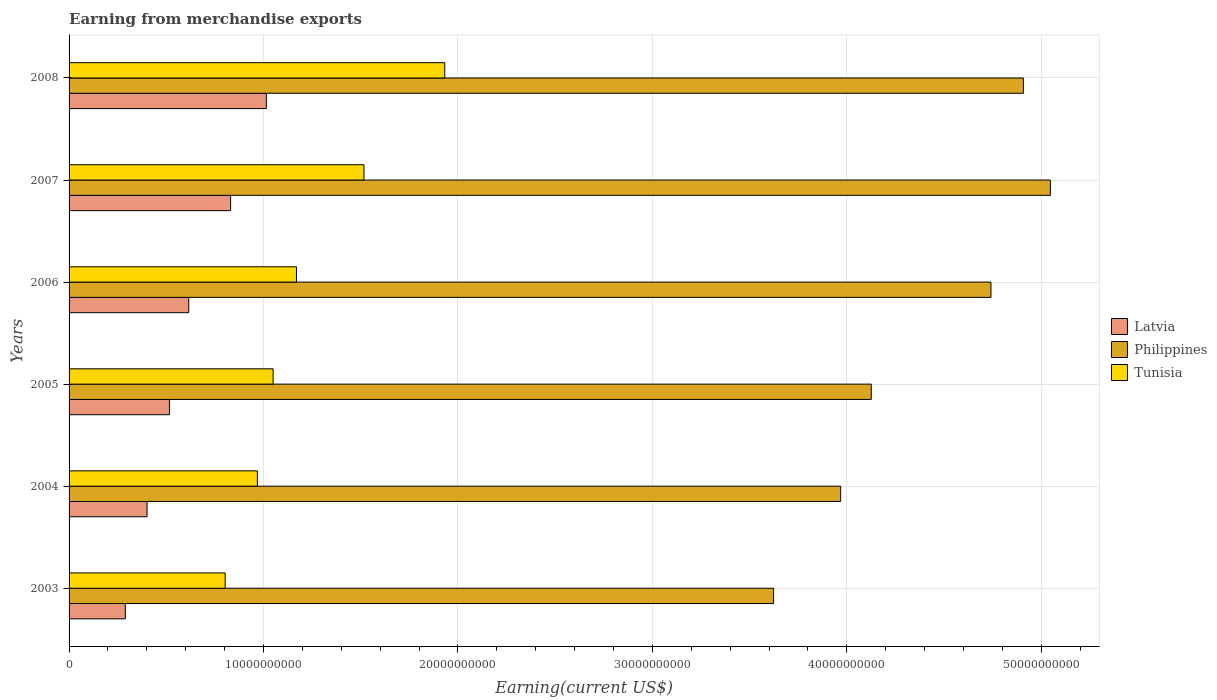How many different coloured bars are there?
Provide a short and direct response. 3. Are the number of bars per tick equal to the number of legend labels?
Ensure brevity in your answer.  Yes. How many bars are there on the 5th tick from the top?
Keep it short and to the point. 3. How many bars are there on the 6th tick from the bottom?
Make the answer very short. 3. What is the label of the 5th group of bars from the top?
Ensure brevity in your answer.  2004. In how many cases, is the number of bars for a given year not equal to the number of legend labels?
Make the answer very short. 0. What is the amount earned from merchandise exports in Latvia in 2004?
Ensure brevity in your answer.  4.01e+09. Across all years, what is the maximum amount earned from merchandise exports in Philippines?
Give a very brief answer. 5.05e+1. Across all years, what is the minimum amount earned from merchandise exports in Tunisia?
Provide a short and direct response. 8.03e+09. In which year was the amount earned from merchandise exports in Tunisia minimum?
Your response must be concise. 2003. What is the total amount earned from merchandise exports in Latvia in the graph?
Offer a terse response. 3.67e+1. What is the difference between the amount earned from merchandise exports in Philippines in 2003 and that in 2004?
Your answer should be compact. -3.45e+09. What is the difference between the amount earned from merchandise exports in Tunisia in 2006 and the amount earned from merchandise exports in Philippines in 2007?
Give a very brief answer. -3.88e+1. What is the average amount earned from merchandise exports in Tunisia per year?
Offer a very short reply. 1.24e+1. In the year 2006, what is the difference between the amount earned from merchandise exports in Philippines and amount earned from merchandise exports in Tunisia?
Your answer should be compact. 3.57e+1. In how many years, is the amount earned from merchandise exports in Latvia greater than 8000000000 US$?
Provide a short and direct response. 2. What is the ratio of the amount earned from merchandise exports in Latvia in 2003 to that in 2006?
Your answer should be very brief. 0.47. Is the amount earned from merchandise exports in Tunisia in 2004 less than that in 2005?
Offer a terse response. Yes. Is the difference between the amount earned from merchandise exports in Philippines in 2003 and 2007 greater than the difference between the amount earned from merchandise exports in Tunisia in 2003 and 2007?
Your answer should be very brief. No. What is the difference between the highest and the second highest amount earned from merchandise exports in Latvia?
Give a very brief answer. 1.84e+09. What is the difference between the highest and the lowest amount earned from merchandise exports in Philippines?
Ensure brevity in your answer.  1.42e+1. In how many years, is the amount earned from merchandise exports in Tunisia greater than the average amount earned from merchandise exports in Tunisia taken over all years?
Ensure brevity in your answer.  2. What does the 3rd bar from the top in 2006 represents?
Give a very brief answer. Latvia. What does the 1st bar from the bottom in 2007 represents?
Keep it short and to the point. Latvia. How many bars are there?
Offer a terse response. 18. How many years are there in the graph?
Your answer should be very brief. 6. Are the values on the major ticks of X-axis written in scientific E-notation?
Your answer should be very brief. No. How are the legend labels stacked?
Provide a succinct answer. Vertical. What is the title of the graph?
Your response must be concise. Earning from merchandise exports. Does "Middle East & North Africa (developing only)" appear as one of the legend labels in the graph?
Provide a short and direct response. No. What is the label or title of the X-axis?
Give a very brief answer. Earning(current US$). What is the Earning(current US$) of Latvia in 2003?
Your answer should be very brief. 2.89e+09. What is the Earning(current US$) in Philippines in 2003?
Make the answer very short. 3.62e+1. What is the Earning(current US$) in Tunisia in 2003?
Ensure brevity in your answer.  8.03e+09. What is the Earning(current US$) in Latvia in 2004?
Offer a very short reply. 4.01e+09. What is the Earning(current US$) of Philippines in 2004?
Give a very brief answer. 3.97e+1. What is the Earning(current US$) of Tunisia in 2004?
Provide a succinct answer. 9.68e+09. What is the Earning(current US$) of Latvia in 2005?
Your response must be concise. 5.16e+09. What is the Earning(current US$) of Philippines in 2005?
Offer a terse response. 4.13e+1. What is the Earning(current US$) of Tunisia in 2005?
Your answer should be very brief. 1.05e+1. What is the Earning(current US$) of Latvia in 2006?
Your answer should be very brief. 6.15e+09. What is the Earning(current US$) of Philippines in 2006?
Your response must be concise. 4.74e+1. What is the Earning(current US$) in Tunisia in 2006?
Make the answer very short. 1.17e+1. What is the Earning(current US$) in Latvia in 2007?
Your answer should be compact. 8.31e+09. What is the Earning(current US$) in Philippines in 2007?
Your response must be concise. 5.05e+1. What is the Earning(current US$) of Tunisia in 2007?
Give a very brief answer. 1.52e+1. What is the Earning(current US$) in Latvia in 2008?
Make the answer very short. 1.01e+1. What is the Earning(current US$) in Philippines in 2008?
Offer a terse response. 4.91e+1. What is the Earning(current US$) of Tunisia in 2008?
Ensure brevity in your answer.  1.93e+1. Across all years, what is the maximum Earning(current US$) of Latvia?
Make the answer very short. 1.01e+1. Across all years, what is the maximum Earning(current US$) of Philippines?
Your answer should be compact. 5.05e+1. Across all years, what is the maximum Earning(current US$) of Tunisia?
Your answer should be very brief. 1.93e+1. Across all years, what is the minimum Earning(current US$) of Latvia?
Your answer should be compact. 2.89e+09. Across all years, what is the minimum Earning(current US$) of Philippines?
Your answer should be very brief. 3.62e+1. Across all years, what is the minimum Earning(current US$) in Tunisia?
Keep it short and to the point. 8.03e+09. What is the total Earning(current US$) in Latvia in the graph?
Offer a terse response. 3.67e+1. What is the total Earning(current US$) of Philippines in the graph?
Give a very brief answer. 2.64e+11. What is the total Earning(current US$) in Tunisia in the graph?
Your answer should be very brief. 7.44e+1. What is the difference between the Earning(current US$) in Latvia in 2003 and that in 2004?
Ensure brevity in your answer.  -1.12e+09. What is the difference between the Earning(current US$) of Philippines in 2003 and that in 2004?
Ensure brevity in your answer.  -3.45e+09. What is the difference between the Earning(current US$) in Tunisia in 2003 and that in 2004?
Your answer should be compact. -1.66e+09. What is the difference between the Earning(current US$) of Latvia in 2003 and that in 2005?
Make the answer very short. -2.27e+09. What is the difference between the Earning(current US$) in Philippines in 2003 and that in 2005?
Offer a terse response. -5.02e+09. What is the difference between the Earning(current US$) of Tunisia in 2003 and that in 2005?
Provide a short and direct response. -2.47e+09. What is the difference between the Earning(current US$) of Latvia in 2003 and that in 2006?
Offer a very short reply. -3.26e+09. What is the difference between the Earning(current US$) in Philippines in 2003 and that in 2006?
Make the answer very short. -1.12e+1. What is the difference between the Earning(current US$) in Tunisia in 2003 and that in 2006?
Offer a very short reply. -3.67e+09. What is the difference between the Earning(current US$) of Latvia in 2003 and that in 2007?
Make the answer very short. -5.42e+09. What is the difference between the Earning(current US$) of Philippines in 2003 and that in 2007?
Your response must be concise. -1.42e+1. What is the difference between the Earning(current US$) in Tunisia in 2003 and that in 2007?
Your answer should be very brief. -7.14e+09. What is the difference between the Earning(current US$) of Latvia in 2003 and that in 2008?
Your response must be concise. -7.25e+09. What is the difference between the Earning(current US$) of Philippines in 2003 and that in 2008?
Offer a very short reply. -1.28e+1. What is the difference between the Earning(current US$) in Tunisia in 2003 and that in 2008?
Ensure brevity in your answer.  -1.13e+1. What is the difference between the Earning(current US$) in Latvia in 2004 and that in 2005?
Provide a short and direct response. -1.15e+09. What is the difference between the Earning(current US$) in Philippines in 2004 and that in 2005?
Provide a short and direct response. -1.57e+09. What is the difference between the Earning(current US$) in Tunisia in 2004 and that in 2005?
Ensure brevity in your answer.  -8.09e+08. What is the difference between the Earning(current US$) of Latvia in 2004 and that in 2006?
Offer a very short reply. -2.15e+09. What is the difference between the Earning(current US$) of Philippines in 2004 and that in 2006?
Make the answer very short. -7.73e+09. What is the difference between the Earning(current US$) in Tunisia in 2004 and that in 2006?
Your answer should be very brief. -2.01e+09. What is the difference between the Earning(current US$) in Latvia in 2004 and that in 2007?
Give a very brief answer. -4.30e+09. What is the difference between the Earning(current US$) in Philippines in 2004 and that in 2007?
Give a very brief answer. -1.08e+1. What is the difference between the Earning(current US$) in Tunisia in 2004 and that in 2007?
Offer a very short reply. -5.48e+09. What is the difference between the Earning(current US$) of Latvia in 2004 and that in 2008?
Your answer should be very brief. -6.14e+09. What is the difference between the Earning(current US$) in Philippines in 2004 and that in 2008?
Ensure brevity in your answer.  -9.40e+09. What is the difference between the Earning(current US$) in Tunisia in 2004 and that in 2008?
Your answer should be compact. -9.64e+09. What is the difference between the Earning(current US$) in Latvia in 2005 and that in 2006?
Provide a succinct answer. -9.94e+08. What is the difference between the Earning(current US$) of Philippines in 2005 and that in 2006?
Provide a short and direct response. -6.16e+09. What is the difference between the Earning(current US$) of Tunisia in 2005 and that in 2006?
Give a very brief answer. -1.20e+09. What is the difference between the Earning(current US$) of Latvia in 2005 and that in 2007?
Offer a terse response. -3.15e+09. What is the difference between the Earning(current US$) in Philippines in 2005 and that in 2007?
Ensure brevity in your answer.  -9.21e+09. What is the difference between the Earning(current US$) in Tunisia in 2005 and that in 2007?
Give a very brief answer. -4.67e+09. What is the difference between the Earning(current US$) of Latvia in 2005 and that in 2008?
Provide a succinct answer. -4.98e+09. What is the difference between the Earning(current US$) in Philippines in 2005 and that in 2008?
Ensure brevity in your answer.  -7.82e+09. What is the difference between the Earning(current US$) of Tunisia in 2005 and that in 2008?
Your answer should be very brief. -8.83e+09. What is the difference between the Earning(current US$) in Latvia in 2006 and that in 2007?
Give a very brief answer. -2.15e+09. What is the difference between the Earning(current US$) in Philippines in 2006 and that in 2007?
Keep it short and to the point. -3.06e+09. What is the difference between the Earning(current US$) of Tunisia in 2006 and that in 2007?
Ensure brevity in your answer.  -3.47e+09. What is the difference between the Earning(current US$) in Latvia in 2006 and that in 2008?
Your answer should be compact. -3.99e+09. What is the difference between the Earning(current US$) in Philippines in 2006 and that in 2008?
Offer a very short reply. -1.67e+09. What is the difference between the Earning(current US$) of Tunisia in 2006 and that in 2008?
Give a very brief answer. -7.63e+09. What is the difference between the Earning(current US$) of Latvia in 2007 and that in 2008?
Offer a terse response. -1.84e+09. What is the difference between the Earning(current US$) in Philippines in 2007 and that in 2008?
Ensure brevity in your answer.  1.39e+09. What is the difference between the Earning(current US$) of Tunisia in 2007 and that in 2008?
Give a very brief answer. -4.15e+09. What is the difference between the Earning(current US$) in Latvia in 2003 and the Earning(current US$) in Philippines in 2004?
Ensure brevity in your answer.  -3.68e+1. What is the difference between the Earning(current US$) in Latvia in 2003 and the Earning(current US$) in Tunisia in 2004?
Make the answer very short. -6.79e+09. What is the difference between the Earning(current US$) of Philippines in 2003 and the Earning(current US$) of Tunisia in 2004?
Your response must be concise. 2.65e+1. What is the difference between the Earning(current US$) in Latvia in 2003 and the Earning(current US$) in Philippines in 2005?
Give a very brief answer. -3.84e+1. What is the difference between the Earning(current US$) in Latvia in 2003 and the Earning(current US$) in Tunisia in 2005?
Your response must be concise. -7.60e+09. What is the difference between the Earning(current US$) of Philippines in 2003 and the Earning(current US$) of Tunisia in 2005?
Ensure brevity in your answer.  2.57e+1. What is the difference between the Earning(current US$) of Latvia in 2003 and the Earning(current US$) of Philippines in 2006?
Give a very brief answer. -4.45e+1. What is the difference between the Earning(current US$) of Latvia in 2003 and the Earning(current US$) of Tunisia in 2006?
Your response must be concise. -8.80e+09. What is the difference between the Earning(current US$) of Philippines in 2003 and the Earning(current US$) of Tunisia in 2006?
Provide a short and direct response. 2.45e+1. What is the difference between the Earning(current US$) in Latvia in 2003 and the Earning(current US$) in Philippines in 2007?
Provide a short and direct response. -4.76e+1. What is the difference between the Earning(current US$) in Latvia in 2003 and the Earning(current US$) in Tunisia in 2007?
Keep it short and to the point. -1.23e+1. What is the difference between the Earning(current US$) of Philippines in 2003 and the Earning(current US$) of Tunisia in 2007?
Keep it short and to the point. 2.11e+1. What is the difference between the Earning(current US$) in Latvia in 2003 and the Earning(current US$) in Philippines in 2008?
Provide a short and direct response. -4.62e+1. What is the difference between the Earning(current US$) of Latvia in 2003 and the Earning(current US$) of Tunisia in 2008?
Your answer should be very brief. -1.64e+1. What is the difference between the Earning(current US$) in Philippines in 2003 and the Earning(current US$) in Tunisia in 2008?
Offer a very short reply. 1.69e+1. What is the difference between the Earning(current US$) of Latvia in 2004 and the Earning(current US$) of Philippines in 2005?
Provide a short and direct response. -3.72e+1. What is the difference between the Earning(current US$) of Latvia in 2004 and the Earning(current US$) of Tunisia in 2005?
Offer a terse response. -6.48e+09. What is the difference between the Earning(current US$) in Philippines in 2004 and the Earning(current US$) in Tunisia in 2005?
Offer a terse response. 2.92e+1. What is the difference between the Earning(current US$) of Latvia in 2004 and the Earning(current US$) of Philippines in 2006?
Offer a very short reply. -4.34e+1. What is the difference between the Earning(current US$) of Latvia in 2004 and the Earning(current US$) of Tunisia in 2006?
Provide a short and direct response. -7.69e+09. What is the difference between the Earning(current US$) of Philippines in 2004 and the Earning(current US$) of Tunisia in 2006?
Your answer should be compact. 2.80e+1. What is the difference between the Earning(current US$) of Latvia in 2004 and the Earning(current US$) of Philippines in 2007?
Give a very brief answer. -4.65e+1. What is the difference between the Earning(current US$) of Latvia in 2004 and the Earning(current US$) of Tunisia in 2007?
Provide a succinct answer. -1.12e+1. What is the difference between the Earning(current US$) of Philippines in 2004 and the Earning(current US$) of Tunisia in 2007?
Keep it short and to the point. 2.45e+1. What is the difference between the Earning(current US$) in Latvia in 2004 and the Earning(current US$) in Philippines in 2008?
Make the answer very short. -4.51e+1. What is the difference between the Earning(current US$) of Latvia in 2004 and the Earning(current US$) of Tunisia in 2008?
Give a very brief answer. -1.53e+1. What is the difference between the Earning(current US$) in Philippines in 2004 and the Earning(current US$) in Tunisia in 2008?
Your answer should be compact. 2.04e+1. What is the difference between the Earning(current US$) of Latvia in 2005 and the Earning(current US$) of Philippines in 2006?
Give a very brief answer. -4.22e+1. What is the difference between the Earning(current US$) in Latvia in 2005 and the Earning(current US$) in Tunisia in 2006?
Your answer should be very brief. -6.53e+09. What is the difference between the Earning(current US$) in Philippines in 2005 and the Earning(current US$) in Tunisia in 2006?
Your answer should be very brief. 2.96e+1. What is the difference between the Earning(current US$) in Latvia in 2005 and the Earning(current US$) in Philippines in 2007?
Provide a short and direct response. -4.53e+1. What is the difference between the Earning(current US$) of Latvia in 2005 and the Earning(current US$) of Tunisia in 2007?
Provide a short and direct response. -1.00e+1. What is the difference between the Earning(current US$) of Philippines in 2005 and the Earning(current US$) of Tunisia in 2007?
Give a very brief answer. 2.61e+1. What is the difference between the Earning(current US$) in Latvia in 2005 and the Earning(current US$) in Philippines in 2008?
Offer a very short reply. -4.39e+1. What is the difference between the Earning(current US$) in Latvia in 2005 and the Earning(current US$) in Tunisia in 2008?
Provide a short and direct response. -1.42e+1. What is the difference between the Earning(current US$) of Philippines in 2005 and the Earning(current US$) of Tunisia in 2008?
Your answer should be compact. 2.19e+1. What is the difference between the Earning(current US$) of Latvia in 2006 and the Earning(current US$) of Philippines in 2007?
Make the answer very short. -4.43e+1. What is the difference between the Earning(current US$) in Latvia in 2006 and the Earning(current US$) in Tunisia in 2007?
Keep it short and to the point. -9.01e+09. What is the difference between the Earning(current US$) of Philippines in 2006 and the Earning(current US$) of Tunisia in 2007?
Provide a short and direct response. 3.22e+1. What is the difference between the Earning(current US$) in Latvia in 2006 and the Earning(current US$) in Philippines in 2008?
Offer a very short reply. -4.29e+1. What is the difference between the Earning(current US$) in Latvia in 2006 and the Earning(current US$) in Tunisia in 2008?
Keep it short and to the point. -1.32e+1. What is the difference between the Earning(current US$) in Philippines in 2006 and the Earning(current US$) in Tunisia in 2008?
Ensure brevity in your answer.  2.81e+1. What is the difference between the Earning(current US$) in Latvia in 2007 and the Earning(current US$) in Philippines in 2008?
Provide a short and direct response. -4.08e+1. What is the difference between the Earning(current US$) of Latvia in 2007 and the Earning(current US$) of Tunisia in 2008?
Provide a short and direct response. -1.10e+1. What is the difference between the Earning(current US$) of Philippines in 2007 and the Earning(current US$) of Tunisia in 2008?
Keep it short and to the point. 3.11e+1. What is the average Earning(current US$) in Latvia per year?
Give a very brief answer. 6.11e+09. What is the average Earning(current US$) of Philippines per year?
Make the answer very short. 4.40e+1. What is the average Earning(current US$) in Tunisia per year?
Provide a short and direct response. 1.24e+1. In the year 2003, what is the difference between the Earning(current US$) of Latvia and Earning(current US$) of Philippines?
Make the answer very short. -3.33e+1. In the year 2003, what is the difference between the Earning(current US$) in Latvia and Earning(current US$) in Tunisia?
Keep it short and to the point. -5.13e+09. In the year 2003, what is the difference between the Earning(current US$) in Philippines and Earning(current US$) in Tunisia?
Make the answer very short. 2.82e+1. In the year 2004, what is the difference between the Earning(current US$) in Latvia and Earning(current US$) in Philippines?
Offer a terse response. -3.57e+1. In the year 2004, what is the difference between the Earning(current US$) of Latvia and Earning(current US$) of Tunisia?
Make the answer very short. -5.68e+09. In the year 2004, what is the difference between the Earning(current US$) of Philippines and Earning(current US$) of Tunisia?
Your answer should be compact. 3.00e+1. In the year 2005, what is the difference between the Earning(current US$) in Latvia and Earning(current US$) in Philippines?
Offer a very short reply. -3.61e+1. In the year 2005, what is the difference between the Earning(current US$) in Latvia and Earning(current US$) in Tunisia?
Your response must be concise. -5.33e+09. In the year 2005, what is the difference between the Earning(current US$) of Philippines and Earning(current US$) of Tunisia?
Provide a succinct answer. 3.08e+1. In the year 2006, what is the difference between the Earning(current US$) of Latvia and Earning(current US$) of Philippines?
Offer a terse response. -4.13e+1. In the year 2006, what is the difference between the Earning(current US$) in Latvia and Earning(current US$) in Tunisia?
Offer a very short reply. -5.54e+09. In the year 2006, what is the difference between the Earning(current US$) in Philippines and Earning(current US$) in Tunisia?
Offer a very short reply. 3.57e+1. In the year 2007, what is the difference between the Earning(current US$) of Latvia and Earning(current US$) of Philippines?
Your answer should be very brief. -4.22e+1. In the year 2007, what is the difference between the Earning(current US$) of Latvia and Earning(current US$) of Tunisia?
Your response must be concise. -6.86e+09. In the year 2007, what is the difference between the Earning(current US$) in Philippines and Earning(current US$) in Tunisia?
Offer a very short reply. 3.53e+1. In the year 2008, what is the difference between the Earning(current US$) in Latvia and Earning(current US$) in Philippines?
Provide a short and direct response. -3.89e+1. In the year 2008, what is the difference between the Earning(current US$) of Latvia and Earning(current US$) of Tunisia?
Offer a very short reply. -9.18e+09. In the year 2008, what is the difference between the Earning(current US$) in Philippines and Earning(current US$) in Tunisia?
Provide a succinct answer. 2.98e+1. What is the ratio of the Earning(current US$) in Latvia in 2003 to that in 2004?
Ensure brevity in your answer.  0.72. What is the ratio of the Earning(current US$) of Philippines in 2003 to that in 2004?
Provide a succinct answer. 0.91. What is the ratio of the Earning(current US$) of Tunisia in 2003 to that in 2004?
Your response must be concise. 0.83. What is the ratio of the Earning(current US$) of Latvia in 2003 to that in 2005?
Give a very brief answer. 0.56. What is the ratio of the Earning(current US$) of Philippines in 2003 to that in 2005?
Give a very brief answer. 0.88. What is the ratio of the Earning(current US$) of Tunisia in 2003 to that in 2005?
Provide a short and direct response. 0.76. What is the ratio of the Earning(current US$) in Latvia in 2003 to that in 2006?
Your answer should be compact. 0.47. What is the ratio of the Earning(current US$) in Philippines in 2003 to that in 2006?
Keep it short and to the point. 0.76. What is the ratio of the Earning(current US$) of Tunisia in 2003 to that in 2006?
Make the answer very short. 0.69. What is the ratio of the Earning(current US$) in Latvia in 2003 to that in 2007?
Provide a short and direct response. 0.35. What is the ratio of the Earning(current US$) in Philippines in 2003 to that in 2007?
Your response must be concise. 0.72. What is the ratio of the Earning(current US$) in Tunisia in 2003 to that in 2007?
Your response must be concise. 0.53. What is the ratio of the Earning(current US$) in Latvia in 2003 to that in 2008?
Ensure brevity in your answer.  0.29. What is the ratio of the Earning(current US$) in Philippines in 2003 to that in 2008?
Your answer should be very brief. 0.74. What is the ratio of the Earning(current US$) in Tunisia in 2003 to that in 2008?
Offer a very short reply. 0.42. What is the ratio of the Earning(current US$) in Latvia in 2004 to that in 2005?
Offer a terse response. 0.78. What is the ratio of the Earning(current US$) of Philippines in 2004 to that in 2005?
Make the answer very short. 0.96. What is the ratio of the Earning(current US$) of Tunisia in 2004 to that in 2005?
Offer a terse response. 0.92. What is the ratio of the Earning(current US$) in Latvia in 2004 to that in 2006?
Offer a terse response. 0.65. What is the ratio of the Earning(current US$) in Philippines in 2004 to that in 2006?
Offer a terse response. 0.84. What is the ratio of the Earning(current US$) of Tunisia in 2004 to that in 2006?
Offer a very short reply. 0.83. What is the ratio of the Earning(current US$) in Latvia in 2004 to that in 2007?
Ensure brevity in your answer.  0.48. What is the ratio of the Earning(current US$) in Philippines in 2004 to that in 2007?
Keep it short and to the point. 0.79. What is the ratio of the Earning(current US$) in Tunisia in 2004 to that in 2007?
Make the answer very short. 0.64. What is the ratio of the Earning(current US$) of Latvia in 2004 to that in 2008?
Offer a very short reply. 0.4. What is the ratio of the Earning(current US$) in Philippines in 2004 to that in 2008?
Keep it short and to the point. 0.81. What is the ratio of the Earning(current US$) in Tunisia in 2004 to that in 2008?
Your answer should be very brief. 0.5. What is the ratio of the Earning(current US$) in Latvia in 2005 to that in 2006?
Your answer should be very brief. 0.84. What is the ratio of the Earning(current US$) in Philippines in 2005 to that in 2006?
Provide a succinct answer. 0.87. What is the ratio of the Earning(current US$) in Tunisia in 2005 to that in 2006?
Provide a short and direct response. 0.9. What is the ratio of the Earning(current US$) in Latvia in 2005 to that in 2007?
Offer a terse response. 0.62. What is the ratio of the Earning(current US$) in Philippines in 2005 to that in 2007?
Provide a succinct answer. 0.82. What is the ratio of the Earning(current US$) in Tunisia in 2005 to that in 2007?
Provide a succinct answer. 0.69. What is the ratio of the Earning(current US$) of Latvia in 2005 to that in 2008?
Keep it short and to the point. 0.51. What is the ratio of the Earning(current US$) in Philippines in 2005 to that in 2008?
Offer a very short reply. 0.84. What is the ratio of the Earning(current US$) in Tunisia in 2005 to that in 2008?
Your answer should be compact. 0.54. What is the ratio of the Earning(current US$) of Latvia in 2006 to that in 2007?
Your answer should be very brief. 0.74. What is the ratio of the Earning(current US$) in Philippines in 2006 to that in 2007?
Keep it short and to the point. 0.94. What is the ratio of the Earning(current US$) of Tunisia in 2006 to that in 2007?
Provide a short and direct response. 0.77. What is the ratio of the Earning(current US$) of Latvia in 2006 to that in 2008?
Provide a succinct answer. 0.61. What is the ratio of the Earning(current US$) in Tunisia in 2006 to that in 2008?
Your answer should be compact. 0.61. What is the ratio of the Earning(current US$) of Latvia in 2007 to that in 2008?
Your answer should be compact. 0.82. What is the ratio of the Earning(current US$) of Philippines in 2007 to that in 2008?
Your answer should be very brief. 1.03. What is the ratio of the Earning(current US$) in Tunisia in 2007 to that in 2008?
Offer a terse response. 0.79. What is the difference between the highest and the second highest Earning(current US$) of Latvia?
Give a very brief answer. 1.84e+09. What is the difference between the highest and the second highest Earning(current US$) of Philippines?
Your response must be concise. 1.39e+09. What is the difference between the highest and the second highest Earning(current US$) in Tunisia?
Offer a terse response. 4.15e+09. What is the difference between the highest and the lowest Earning(current US$) in Latvia?
Offer a very short reply. 7.25e+09. What is the difference between the highest and the lowest Earning(current US$) of Philippines?
Provide a short and direct response. 1.42e+1. What is the difference between the highest and the lowest Earning(current US$) of Tunisia?
Provide a short and direct response. 1.13e+1. 